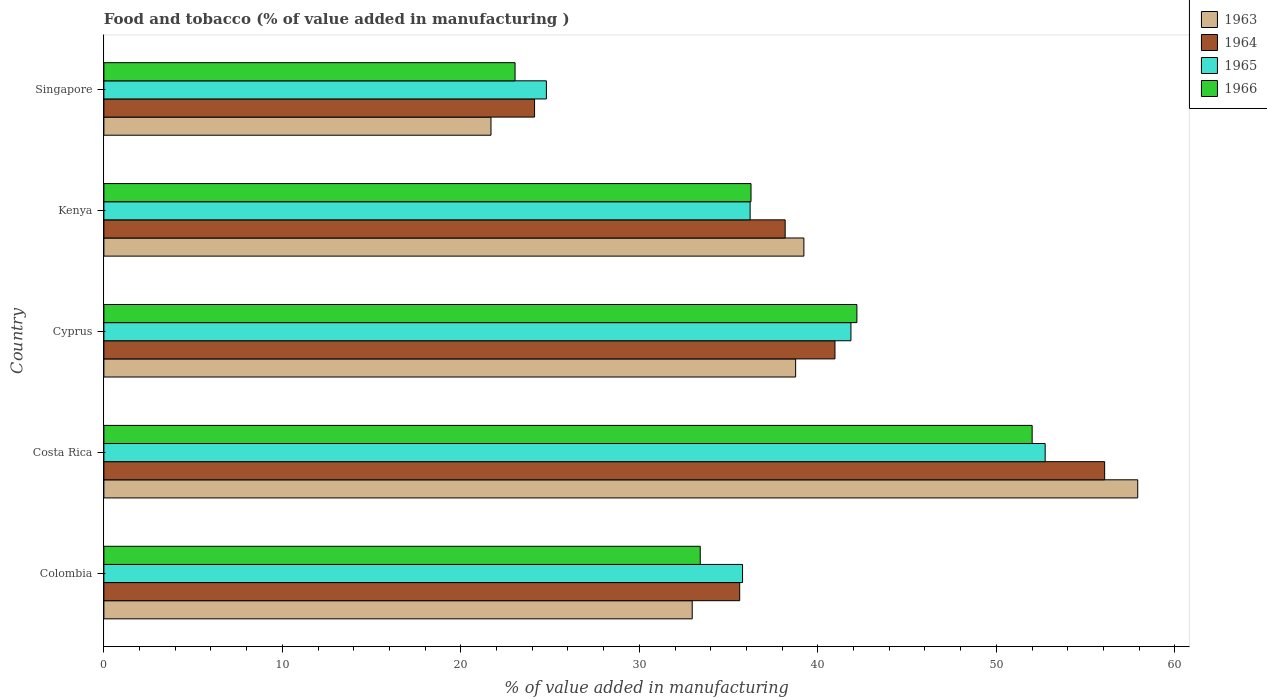Are the number of bars per tick equal to the number of legend labels?
Ensure brevity in your answer.  Yes. What is the label of the 5th group of bars from the top?
Your response must be concise. Colombia. In how many cases, is the number of bars for a given country not equal to the number of legend labels?
Keep it short and to the point. 0. What is the value added in manufacturing food and tobacco in 1964 in Singapore?
Your answer should be compact. 24.13. Across all countries, what is the maximum value added in manufacturing food and tobacco in 1964?
Give a very brief answer. 56.07. Across all countries, what is the minimum value added in manufacturing food and tobacco in 1965?
Ensure brevity in your answer.  24.79. In which country was the value added in manufacturing food and tobacco in 1966 minimum?
Provide a succinct answer. Singapore. What is the total value added in manufacturing food and tobacco in 1963 in the graph?
Keep it short and to the point. 190.54. What is the difference between the value added in manufacturing food and tobacco in 1963 in Costa Rica and that in Kenya?
Offer a terse response. 18.7. What is the difference between the value added in manufacturing food and tobacco in 1966 in Kenya and the value added in manufacturing food and tobacco in 1965 in Cyprus?
Provide a succinct answer. -5.6. What is the average value added in manufacturing food and tobacco in 1966 per country?
Make the answer very short. 37.38. What is the difference between the value added in manufacturing food and tobacco in 1966 and value added in manufacturing food and tobacco in 1965 in Colombia?
Offer a very short reply. -2.37. In how many countries, is the value added in manufacturing food and tobacco in 1963 greater than 52 %?
Offer a terse response. 1. What is the ratio of the value added in manufacturing food and tobacco in 1964 in Colombia to that in Kenya?
Offer a terse response. 0.93. What is the difference between the highest and the second highest value added in manufacturing food and tobacco in 1966?
Keep it short and to the point. 9.82. What is the difference between the highest and the lowest value added in manufacturing food and tobacco in 1965?
Your response must be concise. 27.94. Is the sum of the value added in manufacturing food and tobacco in 1966 in Colombia and Cyprus greater than the maximum value added in manufacturing food and tobacco in 1963 across all countries?
Offer a very short reply. Yes. What does the 2nd bar from the top in Kenya represents?
Provide a succinct answer. 1965. What does the 4th bar from the bottom in Singapore represents?
Your response must be concise. 1966. How many bars are there?
Offer a very short reply. 20. Are all the bars in the graph horizontal?
Your answer should be very brief. Yes. How many countries are there in the graph?
Give a very brief answer. 5. What is the difference between two consecutive major ticks on the X-axis?
Your response must be concise. 10. Are the values on the major ticks of X-axis written in scientific E-notation?
Your answer should be compact. No. Does the graph contain grids?
Give a very brief answer. No. How many legend labels are there?
Your answer should be compact. 4. How are the legend labels stacked?
Offer a very short reply. Vertical. What is the title of the graph?
Your answer should be compact. Food and tobacco (% of value added in manufacturing ). Does "1967" appear as one of the legend labels in the graph?
Ensure brevity in your answer.  No. What is the label or title of the X-axis?
Make the answer very short. % of value added in manufacturing. What is the % of value added in manufacturing of 1963 in Colombia?
Give a very brief answer. 32.96. What is the % of value added in manufacturing of 1964 in Colombia?
Give a very brief answer. 35.62. What is the % of value added in manufacturing of 1965 in Colombia?
Make the answer very short. 35.78. What is the % of value added in manufacturing of 1966 in Colombia?
Provide a short and direct response. 33.41. What is the % of value added in manufacturing in 1963 in Costa Rica?
Offer a terse response. 57.92. What is the % of value added in manufacturing in 1964 in Costa Rica?
Offer a very short reply. 56.07. What is the % of value added in manufacturing in 1965 in Costa Rica?
Make the answer very short. 52.73. What is the % of value added in manufacturing of 1966 in Costa Rica?
Keep it short and to the point. 52. What is the % of value added in manufacturing in 1963 in Cyprus?
Ensure brevity in your answer.  38.75. What is the % of value added in manufacturing of 1964 in Cyprus?
Provide a short and direct response. 40.96. What is the % of value added in manufacturing in 1965 in Cyprus?
Your answer should be compact. 41.85. What is the % of value added in manufacturing in 1966 in Cyprus?
Offer a terse response. 42.19. What is the % of value added in manufacturing in 1963 in Kenya?
Provide a short and direct response. 39.22. What is the % of value added in manufacturing in 1964 in Kenya?
Your response must be concise. 38.17. What is the % of value added in manufacturing of 1965 in Kenya?
Offer a very short reply. 36.2. What is the % of value added in manufacturing of 1966 in Kenya?
Your answer should be compact. 36.25. What is the % of value added in manufacturing of 1963 in Singapore?
Provide a succinct answer. 21.69. What is the % of value added in manufacturing in 1964 in Singapore?
Your answer should be very brief. 24.13. What is the % of value added in manufacturing in 1965 in Singapore?
Your response must be concise. 24.79. What is the % of value added in manufacturing in 1966 in Singapore?
Make the answer very short. 23.04. Across all countries, what is the maximum % of value added in manufacturing in 1963?
Your answer should be compact. 57.92. Across all countries, what is the maximum % of value added in manufacturing in 1964?
Ensure brevity in your answer.  56.07. Across all countries, what is the maximum % of value added in manufacturing of 1965?
Make the answer very short. 52.73. Across all countries, what is the maximum % of value added in manufacturing of 1966?
Ensure brevity in your answer.  52. Across all countries, what is the minimum % of value added in manufacturing in 1963?
Keep it short and to the point. 21.69. Across all countries, what is the minimum % of value added in manufacturing of 1964?
Your answer should be compact. 24.13. Across all countries, what is the minimum % of value added in manufacturing of 1965?
Your response must be concise. 24.79. Across all countries, what is the minimum % of value added in manufacturing in 1966?
Provide a succinct answer. 23.04. What is the total % of value added in manufacturing in 1963 in the graph?
Offer a very short reply. 190.54. What is the total % of value added in manufacturing of 1964 in the graph?
Keep it short and to the point. 194.94. What is the total % of value added in manufacturing in 1965 in the graph?
Keep it short and to the point. 191.36. What is the total % of value added in manufacturing in 1966 in the graph?
Keep it short and to the point. 186.89. What is the difference between the % of value added in manufacturing of 1963 in Colombia and that in Costa Rica?
Make the answer very short. -24.96. What is the difference between the % of value added in manufacturing of 1964 in Colombia and that in Costa Rica?
Provide a short and direct response. -20.45. What is the difference between the % of value added in manufacturing in 1965 in Colombia and that in Costa Rica?
Your response must be concise. -16.95. What is the difference between the % of value added in manufacturing of 1966 in Colombia and that in Costa Rica?
Keep it short and to the point. -18.59. What is the difference between the % of value added in manufacturing in 1963 in Colombia and that in Cyprus?
Your answer should be compact. -5.79. What is the difference between the % of value added in manufacturing of 1964 in Colombia and that in Cyprus?
Your answer should be very brief. -5.34. What is the difference between the % of value added in manufacturing of 1965 in Colombia and that in Cyprus?
Keep it short and to the point. -6.07. What is the difference between the % of value added in manufacturing of 1966 in Colombia and that in Cyprus?
Give a very brief answer. -8.78. What is the difference between the % of value added in manufacturing of 1963 in Colombia and that in Kenya?
Give a very brief answer. -6.26. What is the difference between the % of value added in manufacturing in 1964 in Colombia and that in Kenya?
Provide a succinct answer. -2.55. What is the difference between the % of value added in manufacturing of 1965 in Colombia and that in Kenya?
Offer a very short reply. -0.42. What is the difference between the % of value added in manufacturing of 1966 in Colombia and that in Kenya?
Your answer should be very brief. -2.84. What is the difference between the % of value added in manufacturing of 1963 in Colombia and that in Singapore?
Give a very brief answer. 11.27. What is the difference between the % of value added in manufacturing in 1964 in Colombia and that in Singapore?
Your answer should be very brief. 11.49. What is the difference between the % of value added in manufacturing of 1965 in Colombia and that in Singapore?
Your response must be concise. 10.99. What is the difference between the % of value added in manufacturing of 1966 in Colombia and that in Singapore?
Keep it short and to the point. 10.37. What is the difference between the % of value added in manufacturing of 1963 in Costa Rica and that in Cyprus?
Provide a succinct answer. 19.17. What is the difference between the % of value added in manufacturing in 1964 in Costa Rica and that in Cyprus?
Give a very brief answer. 15.11. What is the difference between the % of value added in manufacturing of 1965 in Costa Rica and that in Cyprus?
Offer a terse response. 10.88. What is the difference between the % of value added in manufacturing of 1966 in Costa Rica and that in Cyprus?
Make the answer very short. 9.82. What is the difference between the % of value added in manufacturing of 1963 in Costa Rica and that in Kenya?
Your response must be concise. 18.7. What is the difference between the % of value added in manufacturing of 1964 in Costa Rica and that in Kenya?
Your response must be concise. 17.9. What is the difference between the % of value added in manufacturing of 1965 in Costa Rica and that in Kenya?
Provide a succinct answer. 16.53. What is the difference between the % of value added in manufacturing of 1966 in Costa Rica and that in Kenya?
Provide a succinct answer. 15.75. What is the difference between the % of value added in manufacturing of 1963 in Costa Rica and that in Singapore?
Your response must be concise. 36.23. What is the difference between the % of value added in manufacturing of 1964 in Costa Rica and that in Singapore?
Provide a succinct answer. 31.94. What is the difference between the % of value added in manufacturing in 1965 in Costa Rica and that in Singapore?
Your response must be concise. 27.94. What is the difference between the % of value added in manufacturing in 1966 in Costa Rica and that in Singapore?
Give a very brief answer. 28.97. What is the difference between the % of value added in manufacturing in 1963 in Cyprus and that in Kenya?
Provide a short and direct response. -0.46. What is the difference between the % of value added in manufacturing in 1964 in Cyprus and that in Kenya?
Your answer should be compact. 2.79. What is the difference between the % of value added in manufacturing in 1965 in Cyprus and that in Kenya?
Provide a short and direct response. 5.65. What is the difference between the % of value added in manufacturing in 1966 in Cyprus and that in Kenya?
Your response must be concise. 5.93. What is the difference between the % of value added in manufacturing of 1963 in Cyprus and that in Singapore?
Your answer should be compact. 17.07. What is the difference between the % of value added in manufacturing of 1964 in Cyprus and that in Singapore?
Give a very brief answer. 16.83. What is the difference between the % of value added in manufacturing in 1965 in Cyprus and that in Singapore?
Offer a terse response. 17.06. What is the difference between the % of value added in manufacturing of 1966 in Cyprus and that in Singapore?
Offer a very short reply. 19.15. What is the difference between the % of value added in manufacturing of 1963 in Kenya and that in Singapore?
Your response must be concise. 17.53. What is the difference between the % of value added in manufacturing of 1964 in Kenya and that in Singapore?
Provide a succinct answer. 14.04. What is the difference between the % of value added in manufacturing in 1965 in Kenya and that in Singapore?
Provide a short and direct response. 11.41. What is the difference between the % of value added in manufacturing of 1966 in Kenya and that in Singapore?
Provide a short and direct response. 13.22. What is the difference between the % of value added in manufacturing in 1963 in Colombia and the % of value added in manufacturing in 1964 in Costa Rica?
Make the answer very short. -23.11. What is the difference between the % of value added in manufacturing in 1963 in Colombia and the % of value added in manufacturing in 1965 in Costa Rica?
Your answer should be very brief. -19.77. What is the difference between the % of value added in manufacturing of 1963 in Colombia and the % of value added in manufacturing of 1966 in Costa Rica?
Provide a short and direct response. -19.04. What is the difference between the % of value added in manufacturing of 1964 in Colombia and the % of value added in manufacturing of 1965 in Costa Rica?
Your answer should be compact. -17.11. What is the difference between the % of value added in manufacturing of 1964 in Colombia and the % of value added in manufacturing of 1966 in Costa Rica?
Keep it short and to the point. -16.38. What is the difference between the % of value added in manufacturing of 1965 in Colombia and the % of value added in manufacturing of 1966 in Costa Rica?
Your answer should be compact. -16.22. What is the difference between the % of value added in manufacturing in 1963 in Colombia and the % of value added in manufacturing in 1964 in Cyprus?
Offer a very short reply. -8. What is the difference between the % of value added in manufacturing in 1963 in Colombia and the % of value added in manufacturing in 1965 in Cyprus?
Offer a very short reply. -8.89. What is the difference between the % of value added in manufacturing in 1963 in Colombia and the % of value added in manufacturing in 1966 in Cyprus?
Ensure brevity in your answer.  -9.23. What is the difference between the % of value added in manufacturing of 1964 in Colombia and the % of value added in manufacturing of 1965 in Cyprus?
Keep it short and to the point. -6.23. What is the difference between the % of value added in manufacturing of 1964 in Colombia and the % of value added in manufacturing of 1966 in Cyprus?
Give a very brief answer. -6.57. What is the difference between the % of value added in manufacturing of 1965 in Colombia and the % of value added in manufacturing of 1966 in Cyprus?
Provide a succinct answer. -6.41. What is the difference between the % of value added in manufacturing of 1963 in Colombia and the % of value added in manufacturing of 1964 in Kenya?
Your answer should be compact. -5.21. What is the difference between the % of value added in manufacturing in 1963 in Colombia and the % of value added in manufacturing in 1965 in Kenya?
Offer a very short reply. -3.24. What is the difference between the % of value added in manufacturing of 1963 in Colombia and the % of value added in manufacturing of 1966 in Kenya?
Your response must be concise. -3.29. What is the difference between the % of value added in manufacturing in 1964 in Colombia and the % of value added in manufacturing in 1965 in Kenya?
Your response must be concise. -0.58. What is the difference between the % of value added in manufacturing of 1964 in Colombia and the % of value added in manufacturing of 1966 in Kenya?
Your answer should be very brief. -0.63. What is the difference between the % of value added in manufacturing in 1965 in Colombia and the % of value added in manufacturing in 1966 in Kenya?
Offer a terse response. -0.47. What is the difference between the % of value added in manufacturing in 1963 in Colombia and the % of value added in manufacturing in 1964 in Singapore?
Provide a succinct answer. 8.83. What is the difference between the % of value added in manufacturing in 1963 in Colombia and the % of value added in manufacturing in 1965 in Singapore?
Your answer should be compact. 8.17. What is the difference between the % of value added in manufacturing in 1963 in Colombia and the % of value added in manufacturing in 1966 in Singapore?
Your answer should be very brief. 9.92. What is the difference between the % of value added in manufacturing in 1964 in Colombia and the % of value added in manufacturing in 1965 in Singapore?
Your answer should be very brief. 10.83. What is the difference between the % of value added in manufacturing of 1964 in Colombia and the % of value added in manufacturing of 1966 in Singapore?
Offer a very short reply. 12.58. What is the difference between the % of value added in manufacturing of 1965 in Colombia and the % of value added in manufacturing of 1966 in Singapore?
Provide a succinct answer. 12.74. What is the difference between the % of value added in manufacturing of 1963 in Costa Rica and the % of value added in manufacturing of 1964 in Cyprus?
Ensure brevity in your answer.  16.96. What is the difference between the % of value added in manufacturing of 1963 in Costa Rica and the % of value added in manufacturing of 1965 in Cyprus?
Keep it short and to the point. 16.07. What is the difference between the % of value added in manufacturing in 1963 in Costa Rica and the % of value added in manufacturing in 1966 in Cyprus?
Your answer should be compact. 15.73. What is the difference between the % of value added in manufacturing of 1964 in Costa Rica and the % of value added in manufacturing of 1965 in Cyprus?
Offer a terse response. 14.21. What is the difference between the % of value added in manufacturing in 1964 in Costa Rica and the % of value added in manufacturing in 1966 in Cyprus?
Your answer should be compact. 13.88. What is the difference between the % of value added in manufacturing in 1965 in Costa Rica and the % of value added in manufacturing in 1966 in Cyprus?
Your response must be concise. 10.55. What is the difference between the % of value added in manufacturing in 1963 in Costa Rica and the % of value added in manufacturing in 1964 in Kenya?
Offer a very short reply. 19.75. What is the difference between the % of value added in manufacturing of 1963 in Costa Rica and the % of value added in manufacturing of 1965 in Kenya?
Keep it short and to the point. 21.72. What is the difference between the % of value added in manufacturing of 1963 in Costa Rica and the % of value added in manufacturing of 1966 in Kenya?
Give a very brief answer. 21.67. What is the difference between the % of value added in manufacturing of 1964 in Costa Rica and the % of value added in manufacturing of 1965 in Kenya?
Make the answer very short. 19.86. What is the difference between the % of value added in manufacturing in 1964 in Costa Rica and the % of value added in manufacturing in 1966 in Kenya?
Offer a very short reply. 19.81. What is the difference between the % of value added in manufacturing of 1965 in Costa Rica and the % of value added in manufacturing of 1966 in Kenya?
Offer a terse response. 16.48. What is the difference between the % of value added in manufacturing in 1963 in Costa Rica and the % of value added in manufacturing in 1964 in Singapore?
Offer a very short reply. 33.79. What is the difference between the % of value added in manufacturing in 1963 in Costa Rica and the % of value added in manufacturing in 1965 in Singapore?
Make the answer very short. 33.13. What is the difference between the % of value added in manufacturing of 1963 in Costa Rica and the % of value added in manufacturing of 1966 in Singapore?
Your answer should be compact. 34.88. What is the difference between the % of value added in manufacturing of 1964 in Costa Rica and the % of value added in manufacturing of 1965 in Singapore?
Your answer should be very brief. 31.28. What is the difference between the % of value added in manufacturing in 1964 in Costa Rica and the % of value added in manufacturing in 1966 in Singapore?
Offer a terse response. 33.03. What is the difference between the % of value added in manufacturing in 1965 in Costa Rica and the % of value added in manufacturing in 1966 in Singapore?
Ensure brevity in your answer.  29.7. What is the difference between the % of value added in manufacturing of 1963 in Cyprus and the % of value added in manufacturing of 1964 in Kenya?
Keep it short and to the point. 0.59. What is the difference between the % of value added in manufacturing in 1963 in Cyprus and the % of value added in manufacturing in 1965 in Kenya?
Give a very brief answer. 2.55. What is the difference between the % of value added in manufacturing of 1963 in Cyprus and the % of value added in manufacturing of 1966 in Kenya?
Your response must be concise. 2.5. What is the difference between the % of value added in manufacturing in 1964 in Cyprus and the % of value added in manufacturing in 1965 in Kenya?
Give a very brief answer. 4.75. What is the difference between the % of value added in manufacturing in 1964 in Cyprus and the % of value added in manufacturing in 1966 in Kenya?
Ensure brevity in your answer.  4.7. What is the difference between the % of value added in manufacturing in 1965 in Cyprus and the % of value added in manufacturing in 1966 in Kenya?
Offer a very short reply. 5.6. What is the difference between the % of value added in manufacturing of 1963 in Cyprus and the % of value added in manufacturing of 1964 in Singapore?
Provide a succinct answer. 14.63. What is the difference between the % of value added in manufacturing of 1963 in Cyprus and the % of value added in manufacturing of 1965 in Singapore?
Make the answer very short. 13.96. What is the difference between the % of value added in manufacturing in 1963 in Cyprus and the % of value added in manufacturing in 1966 in Singapore?
Give a very brief answer. 15.72. What is the difference between the % of value added in manufacturing of 1964 in Cyprus and the % of value added in manufacturing of 1965 in Singapore?
Give a very brief answer. 16.17. What is the difference between the % of value added in manufacturing of 1964 in Cyprus and the % of value added in manufacturing of 1966 in Singapore?
Your response must be concise. 17.92. What is the difference between the % of value added in manufacturing of 1965 in Cyprus and the % of value added in manufacturing of 1966 in Singapore?
Make the answer very short. 18.82. What is the difference between the % of value added in manufacturing of 1963 in Kenya and the % of value added in manufacturing of 1964 in Singapore?
Offer a very short reply. 15.09. What is the difference between the % of value added in manufacturing in 1963 in Kenya and the % of value added in manufacturing in 1965 in Singapore?
Offer a very short reply. 14.43. What is the difference between the % of value added in manufacturing in 1963 in Kenya and the % of value added in manufacturing in 1966 in Singapore?
Make the answer very short. 16.18. What is the difference between the % of value added in manufacturing in 1964 in Kenya and the % of value added in manufacturing in 1965 in Singapore?
Ensure brevity in your answer.  13.38. What is the difference between the % of value added in manufacturing of 1964 in Kenya and the % of value added in manufacturing of 1966 in Singapore?
Give a very brief answer. 15.13. What is the difference between the % of value added in manufacturing of 1965 in Kenya and the % of value added in manufacturing of 1966 in Singapore?
Your answer should be compact. 13.17. What is the average % of value added in manufacturing in 1963 per country?
Give a very brief answer. 38.11. What is the average % of value added in manufacturing of 1964 per country?
Your response must be concise. 38.99. What is the average % of value added in manufacturing in 1965 per country?
Make the answer very short. 38.27. What is the average % of value added in manufacturing of 1966 per country?
Offer a terse response. 37.38. What is the difference between the % of value added in manufacturing of 1963 and % of value added in manufacturing of 1964 in Colombia?
Your answer should be very brief. -2.66. What is the difference between the % of value added in manufacturing of 1963 and % of value added in manufacturing of 1965 in Colombia?
Provide a succinct answer. -2.82. What is the difference between the % of value added in manufacturing in 1963 and % of value added in manufacturing in 1966 in Colombia?
Offer a terse response. -0.45. What is the difference between the % of value added in manufacturing in 1964 and % of value added in manufacturing in 1965 in Colombia?
Your response must be concise. -0.16. What is the difference between the % of value added in manufacturing of 1964 and % of value added in manufacturing of 1966 in Colombia?
Offer a terse response. 2.21. What is the difference between the % of value added in manufacturing of 1965 and % of value added in manufacturing of 1966 in Colombia?
Provide a succinct answer. 2.37. What is the difference between the % of value added in manufacturing of 1963 and % of value added in manufacturing of 1964 in Costa Rica?
Provide a short and direct response. 1.85. What is the difference between the % of value added in manufacturing of 1963 and % of value added in manufacturing of 1965 in Costa Rica?
Offer a very short reply. 5.19. What is the difference between the % of value added in manufacturing of 1963 and % of value added in manufacturing of 1966 in Costa Rica?
Make the answer very short. 5.92. What is the difference between the % of value added in manufacturing of 1964 and % of value added in manufacturing of 1965 in Costa Rica?
Provide a succinct answer. 3.33. What is the difference between the % of value added in manufacturing in 1964 and % of value added in manufacturing in 1966 in Costa Rica?
Your response must be concise. 4.06. What is the difference between the % of value added in manufacturing in 1965 and % of value added in manufacturing in 1966 in Costa Rica?
Your answer should be compact. 0.73. What is the difference between the % of value added in manufacturing of 1963 and % of value added in manufacturing of 1964 in Cyprus?
Ensure brevity in your answer.  -2.2. What is the difference between the % of value added in manufacturing of 1963 and % of value added in manufacturing of 1965 in Cyprus?
Provide a short and direct response. -3.1. What is the difference between the % of value added in manufacturing in 1963 and % of value added in manufacturing in 1966 in Cyprus?
Keep it short and to the point. -3.43. What is the difference between the % of value added in manufacturing in 1964 and % of value added in manufacturing in 1965 in Cyprus?
Your answer should be very brief. -0.9. What is the difference between the % of value added in manufacturing in 1964 and % of value added in manufacturing in 1966 in Cyprus?
Provide a succinct answer. -1.23. What is the difference between the % of value added in manufacturing of 1963 and % of value added in manufacturing of 1964 in Kenya?
Offer a very short reply. 1.05. What is the difference between the % of value added in manufacturing of 1963 and % of value added in manufacturing of 1965 in Kenya?
Keep it short and to the point. 3.01. What is the difference between the % of value added in manufacturing in 1963 and % of value added in manufacturing in 1966 in Kenya?
Make the answer very short. 2.96. What is the difference between the % of value added in manufacturing of 1964 and % of value added in manufacturing of 1965 in Kenya?
Make the answer very short. 1.96. What is the difference between the % of value added in manufacturing in 1964 and % of value added in manufacturing in 1966 in Kenya?
Offer a very short reply. 1.91. What is the difference between the % of value added in manufacturing in 1963 and % of value added in manufacturing in 1964 in Singapore?
Offer a very short reply. -2.44. What is the difference between the % of value added in manufacturing of 1963 and % of value added in manufacturing of 1965 in Singapore?
Your response must be concise. -3.1. What is the difference between the % of value added in manufacturing in 1963 and % of value added in manufacturing in 1966 in Singapore?
Your response must be concise. -1.35. What is the difference between the % of value added in manufacturing of 1964 and % of value added in manufacturing of 1965 in Singapore?
Offer a very short reply. -0.66. What is the difference between the % of value added in manufacturing in 1964 and % of value added in manufacturing in 1966 in Singapore?
Give a very brief answer. 1.09. What is the difference between the % of value added in manufacturing in 1965 and % of value added in manufacturing in 1966 in Singapore?
Make the answer very short. 1.75. What is the ratio of the % of value added in manufacturing of 1963 in Colombia to that in Costa Rica?
Your answer should be compact. 0.57. What is the ratio of the % of value added in manufacturing in 1964 in Colombia to that in Costa Rica?
Your answer should be compact. 0.64. What is the ratio of the % of value added in manufacturing in 1965 in Colombia to that in Costa Rica?
Offer a very short reply. 0.68. What is the ratio of the % of value added in manufacturing of 1966 in Colombia to that in Costa Rica?
Offer a very short reply. 0.64. What is the ratio of the % of value added in manufacturing in 1963 in Colombia to that in Cyprus?
Provide a short and direct response. 0.85. What is the ratio of the % of value added in manufacturing of 1964 in Colombia to that in Cyprus?
Offer a terse response. 0.87. What is the ratio of the % of value added in manufacturing of 1965 in Colombia to that in Cyprus?
Your answer should be compact. 0.85. What is the ratio of the % of value added in manufacturing of 1966 in Colombia to that in Cyprus?
Keep it short and to the point. 0.79. What is the ratio of the % of value added in manufacturing in 1963 in Colombia to that in Kenya?
Offer a very short reply. 0.84. What is the ratio of the % of value added in manufacturing of 1964 in Colombia to that in Kenya?
Provide a succinct answer. 0.93. What is the ratio of the % of value added in manufacturing in 1965 in Colombia to that in Kenya?
Your answer should be compact. 0.99. What is the ratio of the % of value added in manufacturing in 1966 in Colombia to that in Kenya?
Make the answer very short. 0.92. What is the ratio of the % of value added in manufacturing of 1963 in Colombia to that in Singapore?
Your answer should be very brief. 1.52. What is the ratio of the % of value added in manufacturing of 1964 in Colombia to that in Singapore?
Provide a succinct answer. 1.48. What is the ratio of the % of value added in manufacturing of 1965 in Colombia to that in Singapore?
Offer a terse response. 1.44. What is the ratio of the % of value added in manufacturing of 1966 in Colombia to that in Singapore?
Provide a succinct answer. 1.45. What is the ratio of the % of value added in manufacturing of 1963 in Costa Rica to that in Cyprus?
Ensure brevity in your answer.  1.49. What is the ratio of the % of value added in manufacturing in 1964 in Costa Rica to that in Cyprus?
Provide a short and direct response. 1.37. What is the ratio of the % of value added in manufacturing in 1965 in Costa Rica to that in Cyprus?
Your answer should be compact. 1.26. What is the ratio of the % of value added in manufacturing in 1966 in Costa Rica to that in Cyprus?
Provide a short and direct response. 1.23. What is the ratio of the % of value added in manufacturing in 1963 in Costa Rica to that in Kenya?
Offer a terse response. 1.48. What is the ratio of the % of value added in manufacturing of 1964 in Costa Rica to that in Kenya?
Keep it short and to the point. 1.47. What is the ratio of the % of value added in manufacturing in 1965 in Costa Rica to that in Kenya?
Your answer should be compact. 1.46. What is the ratio of the % of value added in manufacturing in 1966 in Costa Rica to that in Kenya?
Keep it short and to the point. 1.43. What is the ratio of the % of value added in manufacturing in 1963 in Costa Rica to that in Singapore?
Keep it short and to the point. 2.67. What is the ratio of the % of value added in manufacturing of 1964 in Costa Rica to that in Singapore?
Your response must be concise. 2.32. What is the ratio of the % of value added in manufacturing in 1965 in Costa Rica to that in Singapore?
Give a very brief answer. 2.13. What is the ratio of the % of value added in manufacturing in 1966 in Costa Rica to that in Singapore?
Make the answer very short. 2.26. What is the ratio of the % of value added in manufacturing of 1963 in Cyprus to that in Kenya?
Provide a short and direct response. 0.99. What is the ratio of the % of value added in manufacturing of 1964 in Cyprus to that in Kenya?
Keep it short and to the point. 1.07. What is the ratio of the % of value added in manufacturing in 1965 in Cyprus to that in Kenya?
Your answer should be very brief. 1.16. What is the ratio of the % of value added in manufacturing of 1966 in Cyprus to that in Kenya?
Make the answer very short. 1.16. What is the ratio of the % of value added in manufacturing in 1963 in Cyprus to that in Singapore?
Ensure brevity in your answer.  1.79. What is the ratio of the % of value added in manufacturing of 1964 in Cyprus to that in Singapore?
Offer a terse response. 1.7. What is the ratio of the % of value added in manufacturing in 1965 in Cyprus to that in Singapore?
Your answer should be compact. 1.69. What is the ratio of the % of value added in manufacturing in 1966 in Cyprus to that in Singapore?
Your answer should be compact. 1.83. What is the ratio of the % of value added in manufacturing in 1963 in Kenya to that in Singapore?
Provide a succinct answer. 1.81. What is the ratio of the % of value added in manufacturing in 1964 in Kenya to that in Singapore?
Your response must be concise. 1.58. What is the ratio of the % of value added in manufacturing of 1965 in Kenya to that in Singapore?
Your answer should be compact. 1.46. What is the ratio of the % of value added in manufacturing in 1966 in Kenya to that in Singapore?
Provide a succinct answer. 1.57. What is the difference between the highest and the second highest % of value added in manufacturing of 1963?
Make the answer very short. 18.7. What is the difference between the highest and the second highest % of value added in manufacturing of 1964?
Your response must be concise. 15.11. What is the difference between the highest and the second highest % of value added in manufacturing in 1965?
Your answer should be compact. 10.88. What is the difference between the highest and the second highest % of value added in manufacturing in 1966?
Offer a very short reply. 9.82. What is the difference between the highest and the lowest % of value added in manufacturing in 1963?
Give a very brief answer. 36.23. What is the difference between the highest and the lowest % of value added in manufacturing of 1964?
Make the answer very short. 31.94. What is the difference between the highest and the lowest % of value added in manufacturing of 1965?
Keep it short and to the point. 27.94. What is the difference between the highest and the lowest % of value added in manufacturing in 1966?
Offer a very short reply. 28.97. 